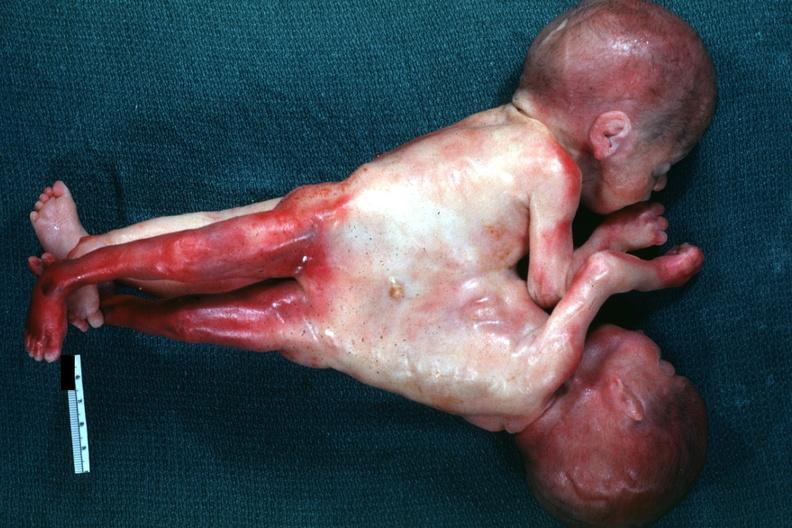does this image show very good example joined abdomen and lower chest anterior?
Answer the question using a single word or phrase. Yes 